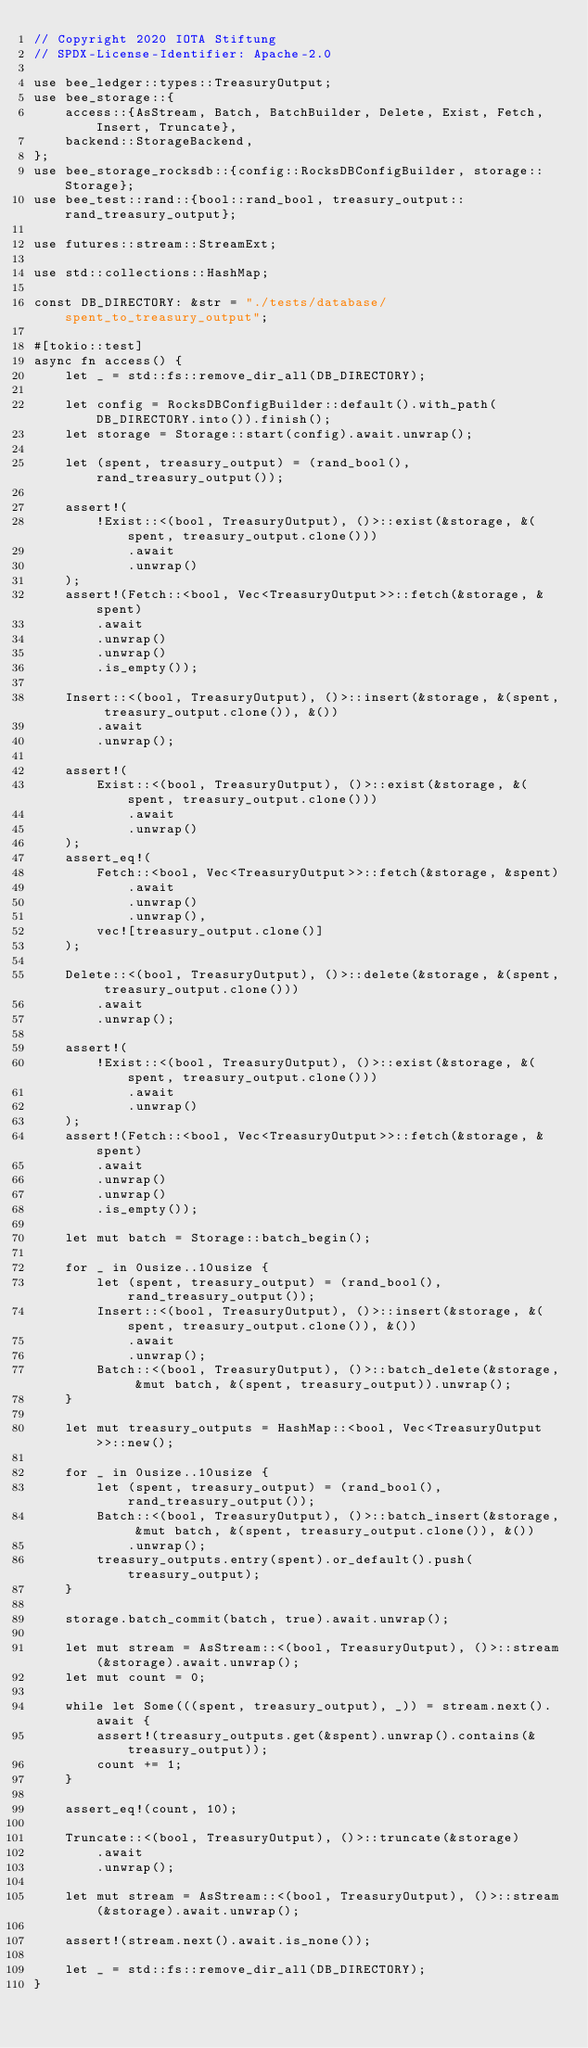<code> <loc_0><loc_0><loc_500><loc_500><_Rust_>// Copyright 2020 IOTA Stiftung
// SPDX-License-Identifier: Apache-2.0

use bee_ledger::types::TreasuryOutput;
use bee_storage::{
    access::{AsStream, Batch, BatchBuilder, Delete, Exist, Fetch, Insert, Truncate},
    backend::StorageBackend,
};
use bee_storage_rocksdb::{config::RocksDBConfigBuilder, storage::Storage};
use bee_test::rand::{bool::rand_bool, treasury_output::rand_treasury_output};

use futures::stream::StreamExt;

use std::collections::HashMap;

const DB_DIRECTORY: &str = "./tests/database/spent_to_treasury_output";

#[tokio::test]
async fn access() {
    let _ = std::fs::remove_dir_all(DB_DIRECTORY);

    let config = RocksDBConfigBuilder::default().with_path(DB_DIRECTORY.into()).finish();
    let storage = Storage::start(config).await.unwrap();

    let (spent, treasury_output) = (rand_bool(), rand_treasury_output());

    assert!(
        !Exist::<(bool, TreasuryOutput), ()>::exist(&storage, &(spent, treasury_output.clone()))
            .await
            .unwrap()
    );
    assert!(Fetch::<bool, Vec<TreasuryOutput>>::fetch(&storage, &spent)
        .await
        .unwrap()
        .unwrap()
        .is_empty());

    Insert::<(bool, TreasuryOutput), ()>::insert(&storage, &(spent, treasury_output.clone()), &())
        .await
        .unwrap();

    assert!(
        Exist::<(bool, TreasuryOutput), ()>::exist(&storage, &(spent, treasury_output.clone()))
            .await
            .unwrap()
    );
    assert_eq!(
        Fetch::<bool, Vec<TreasuryOutput>>::fetch(&storage, &spent)
            .await
            .unwrap()
            .unwrap(),
        vec![treasury_output.clone()]
    );

    Delete::<(bool, TreasuryOutput), ()>::delete(&storage, &(spent, treasury_output.clone()))
        .await
        .unwrap();

    assert!(
        !Exist::<(bool, TreasuryOutput), ()>::exist(&storage, &(spent, treasury_output.clone()))
            .await
            .unwrap()
    );
    assert!(Fetch::<bool, Vec<TreasuryOutput>>::fetch(&storage, &spent)
        .await
        .unwrap()
        .unwrap()
        .is_empty());

    let mut batch = Storage::batch_begin();

    for _ in 0usize..10usize {
        let (spent, treasury_output) = (rand_bool(), rand_treasury_output());
        Insert::<(bool, TreasuryOutput), ()>::insert(&storage, &(spent, treasury_output.clone()), &())
            .await
            .unwrap();
        Batch::<(bool, TreasuryOutput), ()>::batch_delete(&storage, &mut batch, &(spent, treasury_output)).unwrap();
    }

    let mut treasury_outputs = HashMap::<bool, Vec<TreasuryOutput>>::new();

    for _ in 0usize..10usize {
        let (spent, treasury_output) = (rand_bool(), rand_treasury_output());
        Batch::<(bool, TreasuryOutput), ()>::batch_insert(&storage, &mut batch, &(spent, treasury_output.clone()), &())
            .unwrap();
        treasury_outputs.entry(spent).or_default().push(treasury_output);
    }

    storage.batch_commit(batch, true).await.unwrap();

    let mut stream = AsStream::<(bool, TreasuryOutput), ()>::stream(&storage).await.unwrap();
    let mut count = 0;

    while let Some(((spent, treasury_output), _)) = stream.next().await {
        assert!(treasury_outputs.get(&spent).unwrap().contains(&treasury_output));
        count += 1;
    }

    assert_eq!(count, 10);

    Truncate::<(bool, TreasuryOutput), ()>::truncate(&storage)
        .await
        .unwrap();

    let mut stream = AsStream::<(bool, TreasuryOutput), ()>::stream(&storage).await.unwrap();

    assert!(stream.next().await.is_none());

    let _ = std::fs::remove_dir_all(DB_DIRECTORY);
}
</code> 